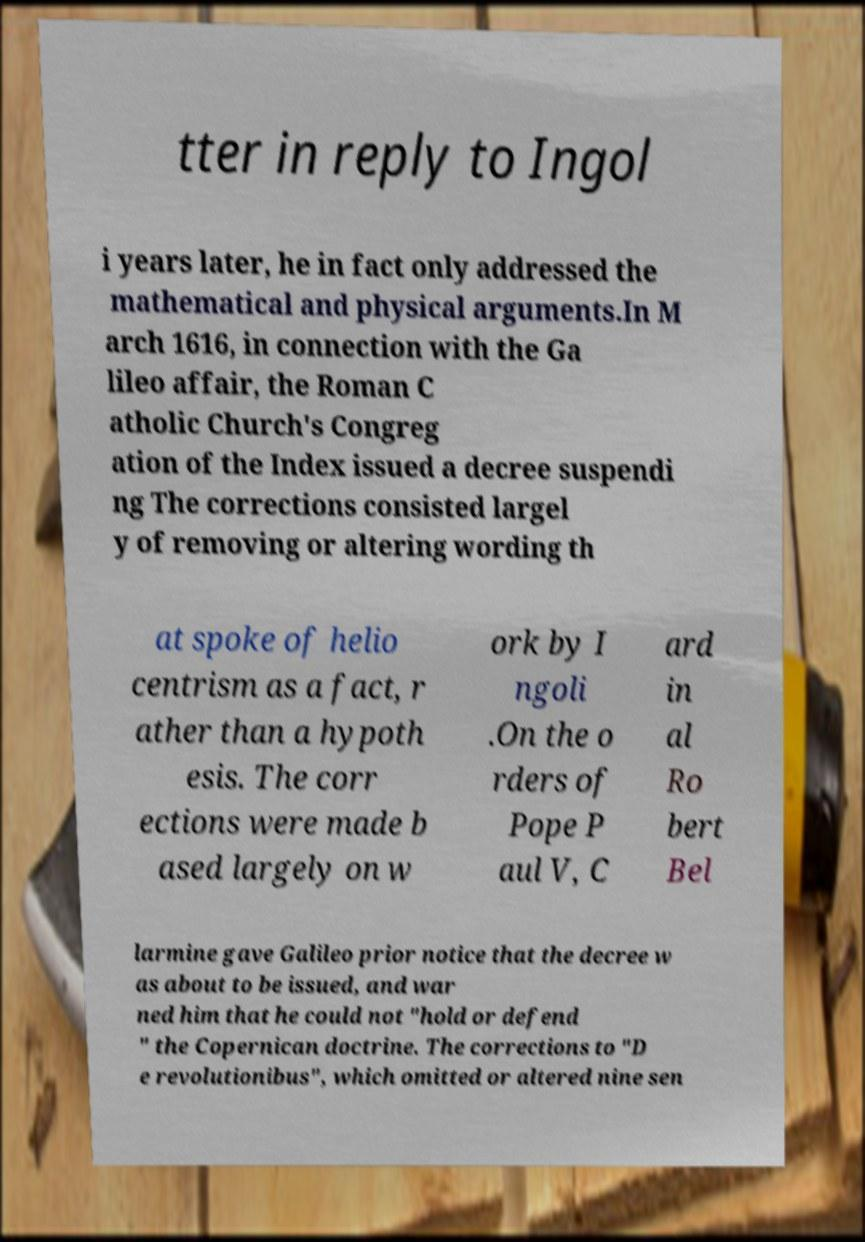Please read and relay the text visible in this image. What does it say? tter in reply to Ingol i years later, he in fact only addressed the mathematical and physical arguments.In M arch 1616, in connection with the Ga lileo affair, the Roman C atholic Church's Congreg ation of the Index issued a decree suspendi ng The corrections consisted largel y of removing or altering wording th at spoke of helio centrism as a fact, r ather than a hypoth esis. The corr ections were made b ased largely on w ork by I ngoli .On the o rders of Pope P aul V, C ard in al Ro bert Bel larmine gave Galileo prior notice that the decree w as about to be issued, and war ned him that he could not "hold or defend " the Copernican doctrine. The corrections to "D e revolutionibus", which omitted or altered nine sen 